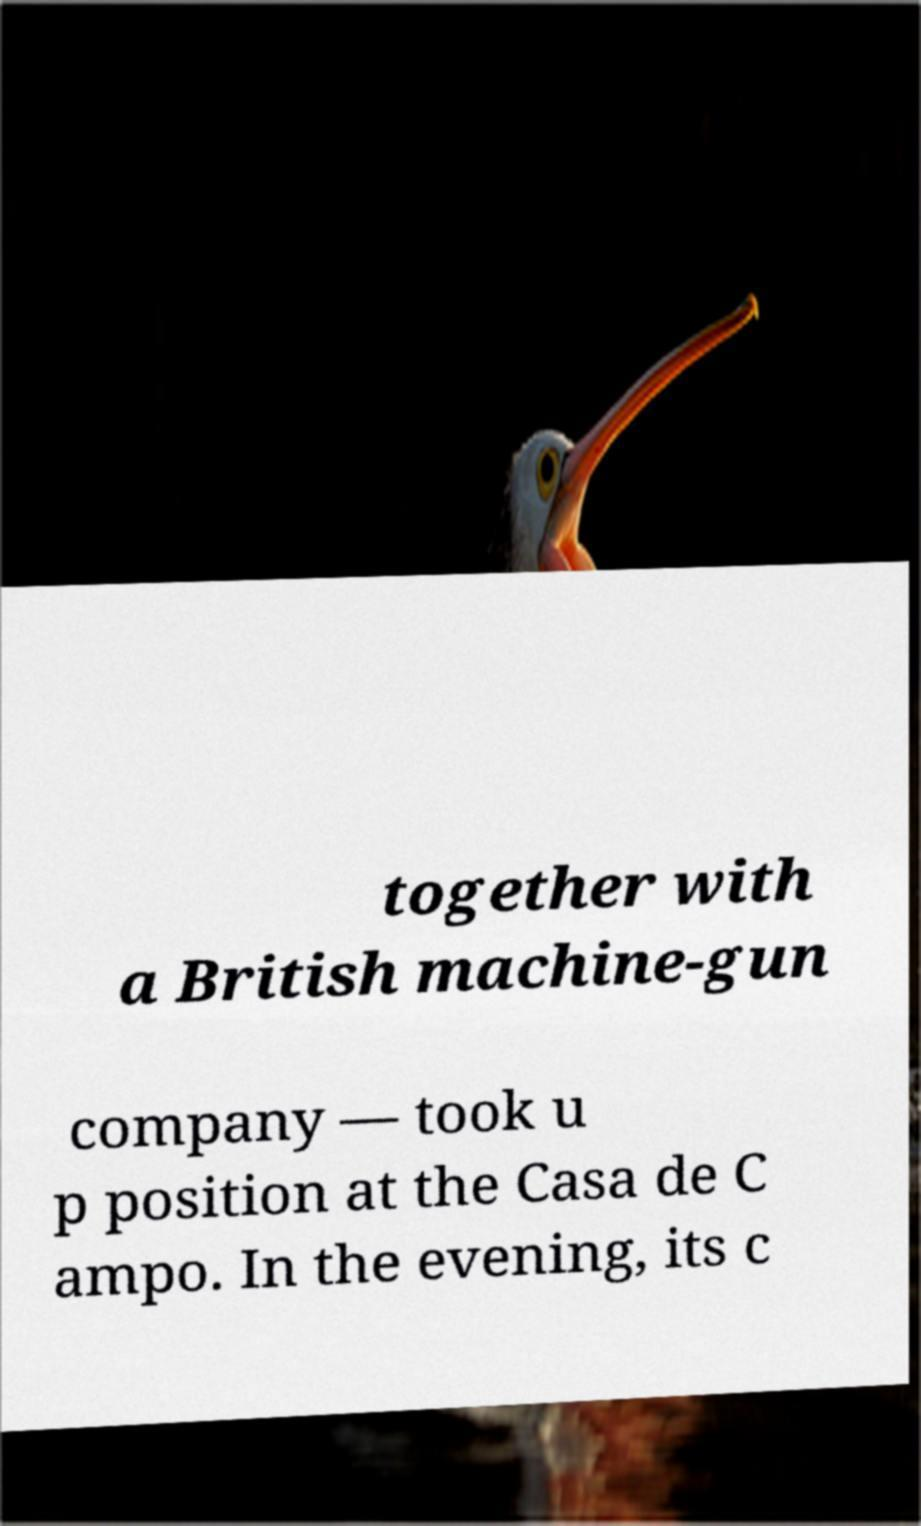Please identify and transcribe the text found in this image. together with a British machine-gun company — took u p position at the Casa de C ampo. In the evening, its c 